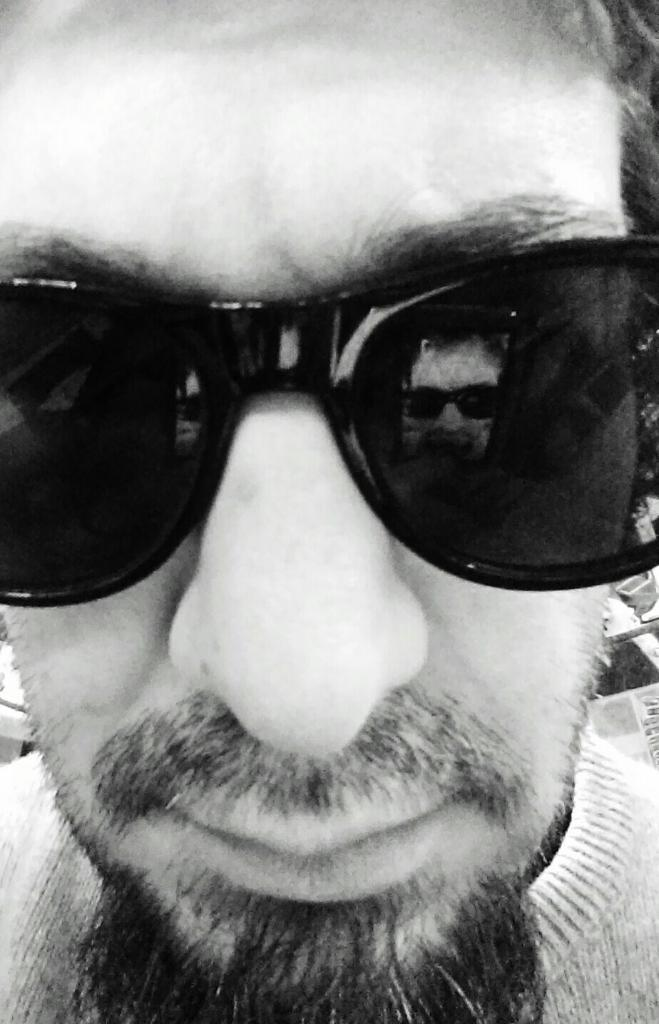What is present in the image? There is a person in the image. Can you describe the person's appearance? The person is wearing specs. What can be inferred about the time of day when the image was taken? The image was likely taken during the day. What type of basket is being used by the person in the image? There is no basket present in the image. What belief system does the person in the image follow? There is no information about the person's belief system in the image. 